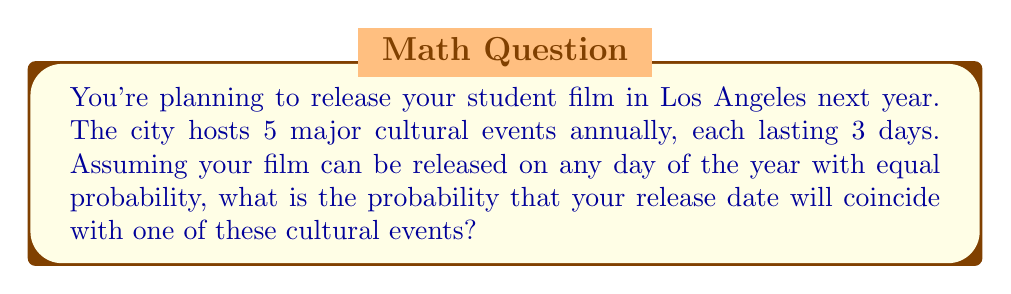What is the answer to this math problem? Let's approach this step-by-step:

1) First, we need to calculate the total number of days covered by cultural events:
   $$ 5 \text{ events} \times 3 \text{ days per event} = 15 \text{ days} $$

2) We assume a non-leap year, so there are 365 days in the year.

3) The probability of the release date coinciding with a cultural event is the number of favorable outcomes (days with events) divided by the total number of possible outcomes (days in the year):

   $$ P(\text{coincidence}) = \frac{\text{number of event days}}{\text{total days in year}} $$

4) Substituting our values:

   $$ P(\text{coincidence}) = \frac{15}{365} $$

5) Simplifying:

   $$ P(\text{coincidence}) = \frac{3}{73} \approx 0.0411 $$

6) This can be expressed as a percentage:

   $$ 0.0411 \times 100\% \approx 4.11\% $$
Answer: $\frac{3}{73}$ or approximately 4.11% 